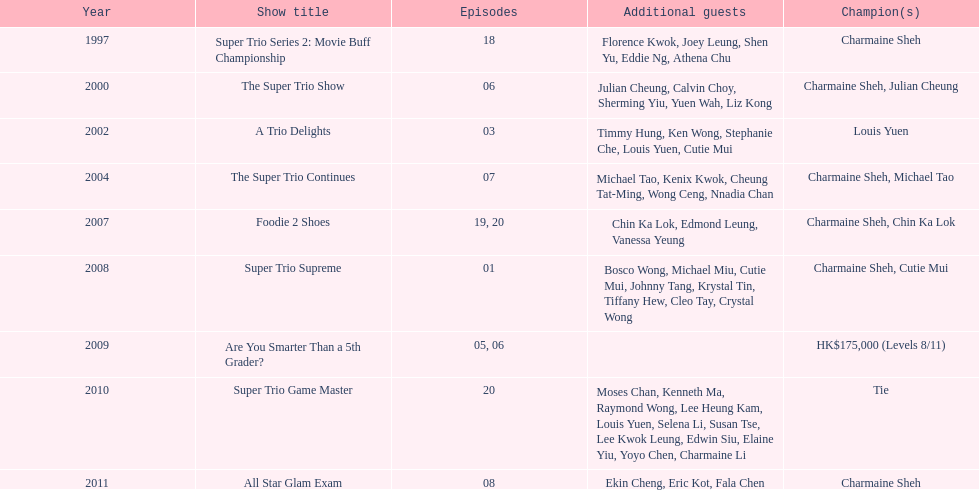How many consecutive trio shows did charmaine sheh do before being on another variety program? 34. 